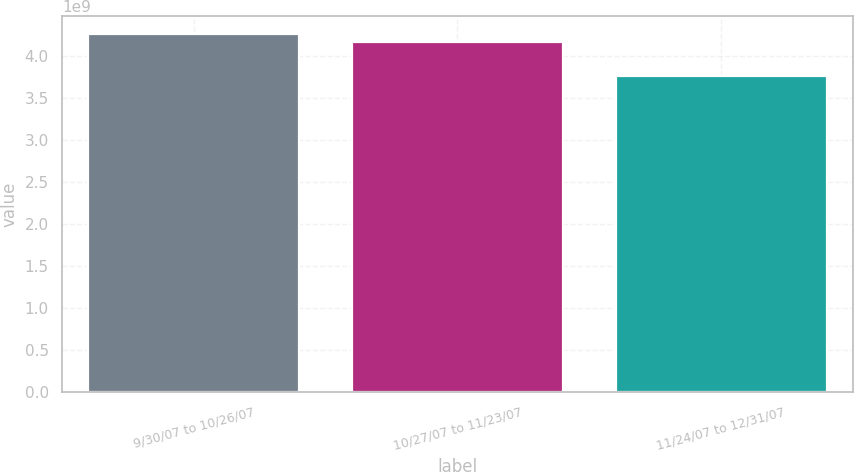<chart> <loc_0><loc_0><loc_500><loc_500><bar_chart><fcel>9/30/07 to 10/26/07<fcel>10/27/07 to 11/23/07<fcel>11/24/07 to 12/31/07<nl><fcel>4.26738e+09<fcel>4.16906e+09<fcel>3.76706e+09<nl></chart> 